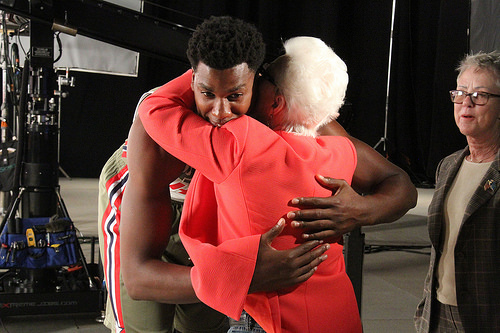<image>
Can you confirm if the woman is behind the man? No. The woman is not behind the man. From this viewpoint, the woman appears to be positioned elsewhere in the scene. 